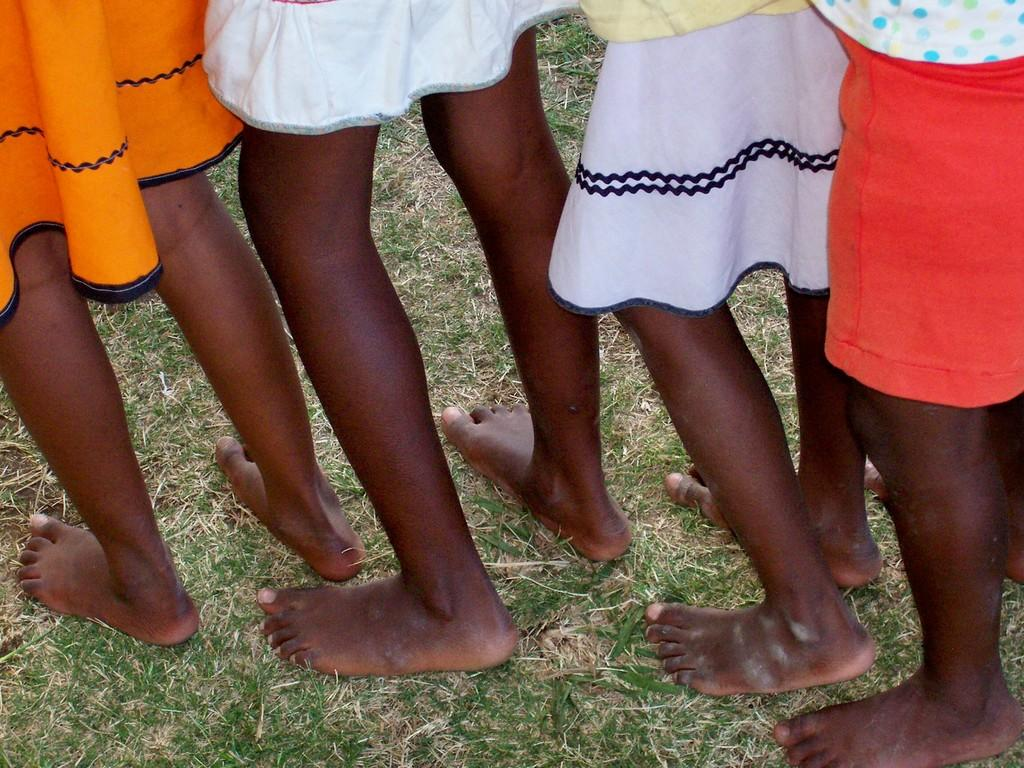What is present in the image? There are people in the image. Where are the people located? The people are standing on the ground. How much of the people can be seen in the image? The image is cropped or zoomed in, causing the people to be partially visible. What type of stream can be seen in the image? There is no stream present in the image; it only features people standing on the ground. Are the people saying good-bye to each other in the image? There is no indication in the image that the people are saying good-bye to each other. 